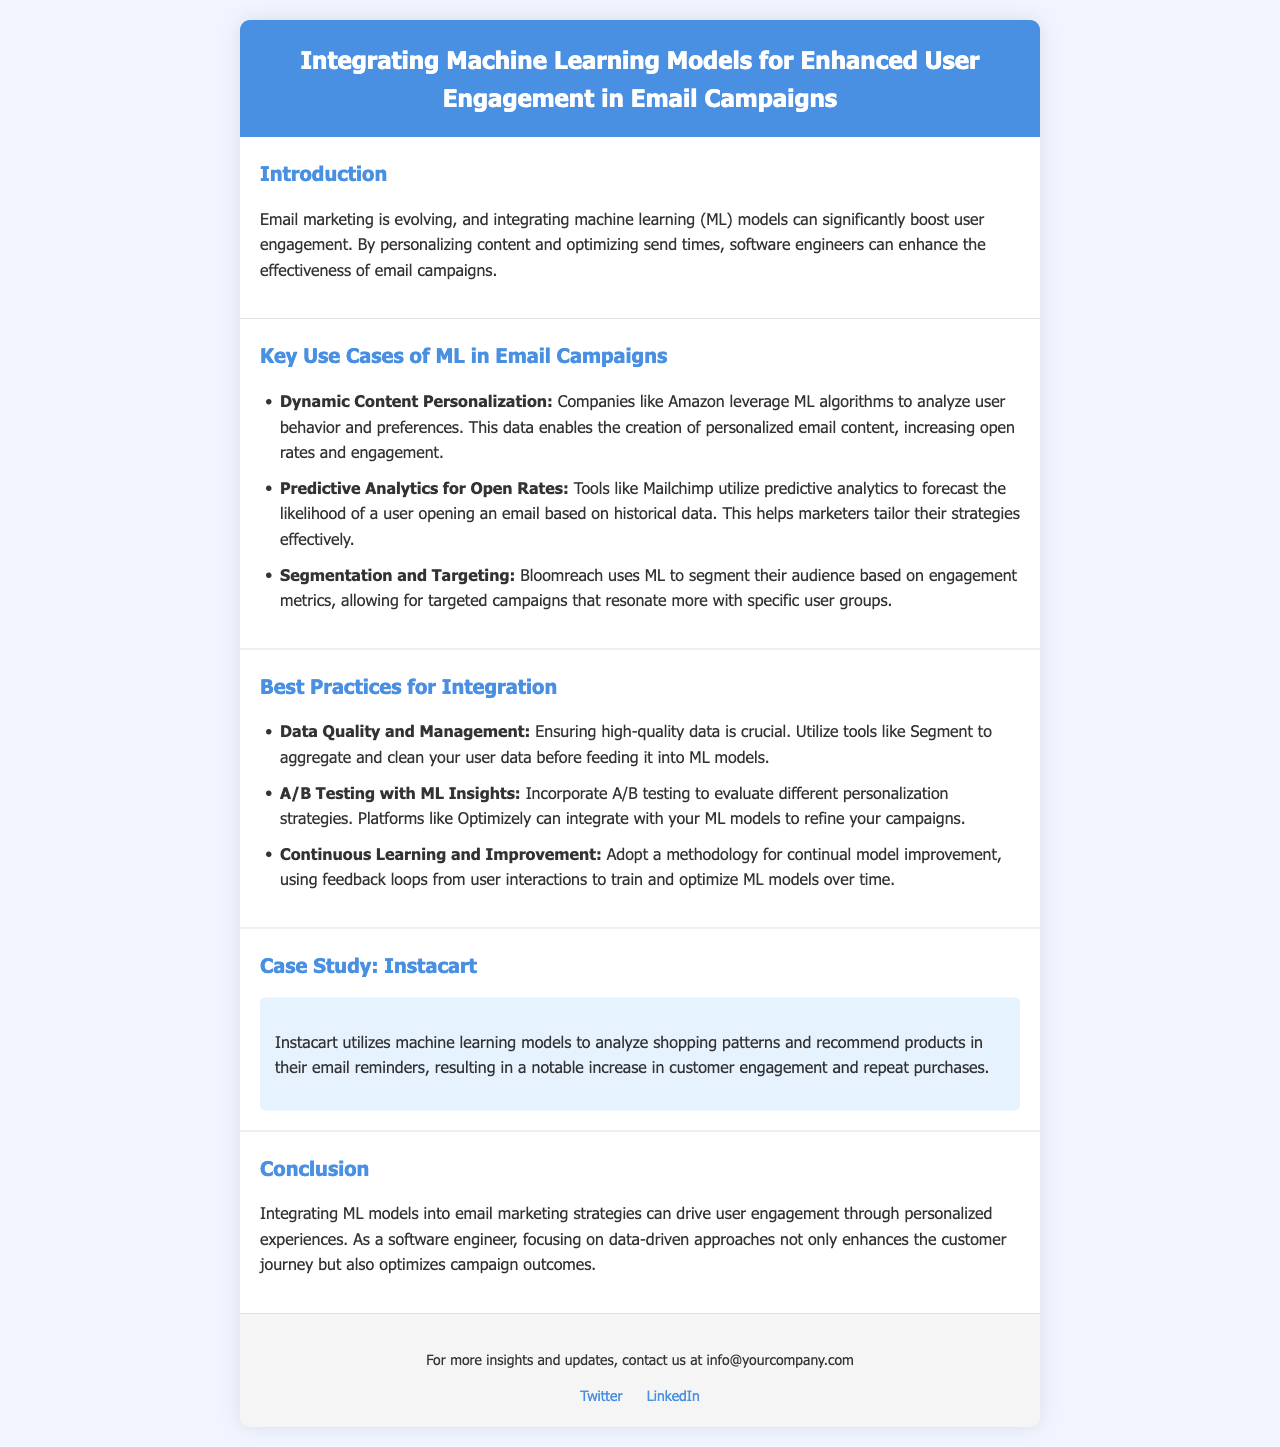What is the title of the newsletter? The title of the newsletter is found in the header section.
Answer: Integrating Machine Learning Models for Enhanced User Engagement in Email Campaigns What company is mentioned as using dynamic content personalization? The document states that Amazon leverages ML algorithms for this purpose.
Answer: Amazon Which tool uses predictive analytics for open rates? The section on key use cases mentions this tool specifically for predicting email open rates.
Answer: Mailchimp What is one of the best practices for data quality mentioned? The document provides a specific recommendation related to managing user data before using it in ML models.
Answer: Utilize tools like Segment What significant outcome did Instacart achieve through machine learning? The case study highlights the specific result of their email strategy relating to customer interaction.
Answer: Notable increase in customer engagement What does the conclusion emphasize about integrating ML models? The conclusion discusses the main benefit of including ML in email marketing strategies.
Answer: Drive user engagement Name one platform that can integrate with ML models for A/B testing. The document identifies a specific platform useful for A/B testing in conjunction with ML.
Answer: Optimizely How does Bloomreach use machine learning in email campaigns? The document describes a specific application of ML by Bloomreach in relation to audience segmentation.
Answer: Segment their audience based on engagement metrics 